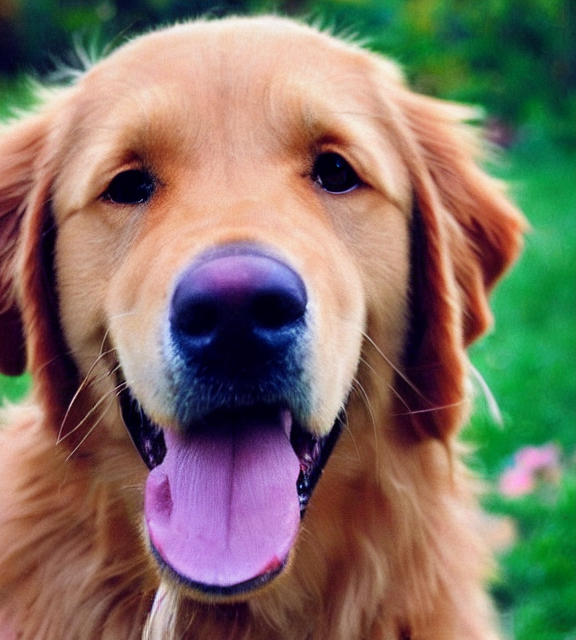What emotions does the dog in the image seem to express? The dog seems to be very happy and content, as it is panting lightly with its tongue out, a common sign of a relaxed and joyful dog. 